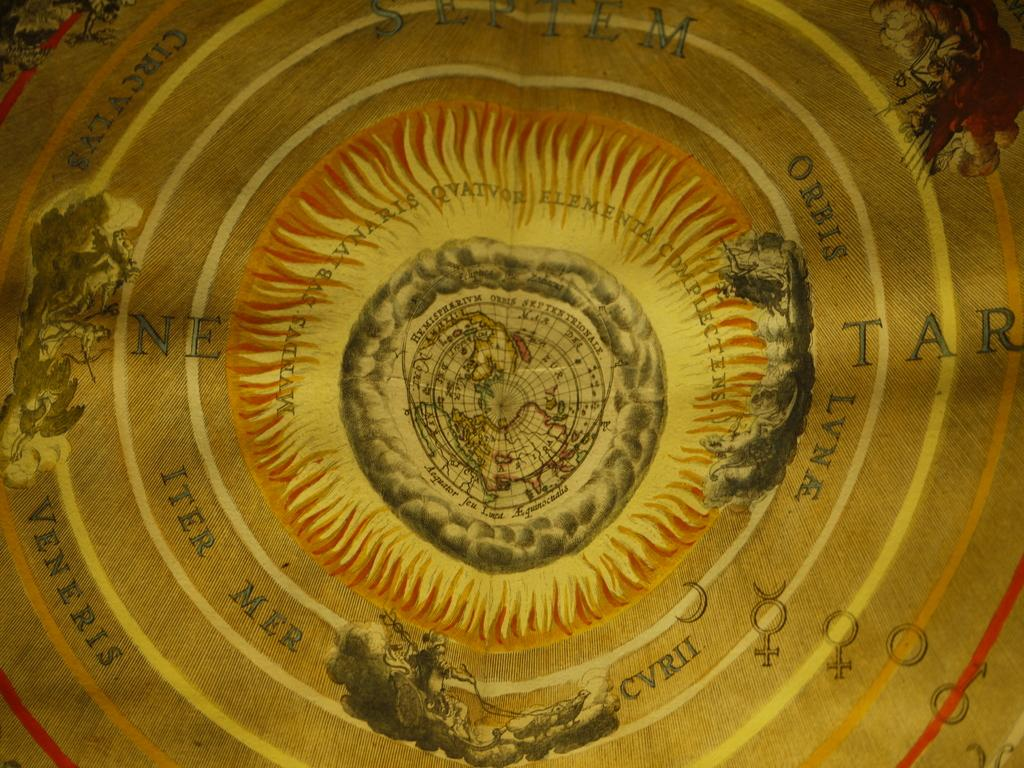What is the main object in the image? There is a board in the image. What can be seen on the board? There are images of people and vehicles depicted on the board. Is there any text on the board? Yes, there is text on the board. What type of building can be seen in the alley behind the board? There is no building or alley present in the image; it only features a board with images and text. 